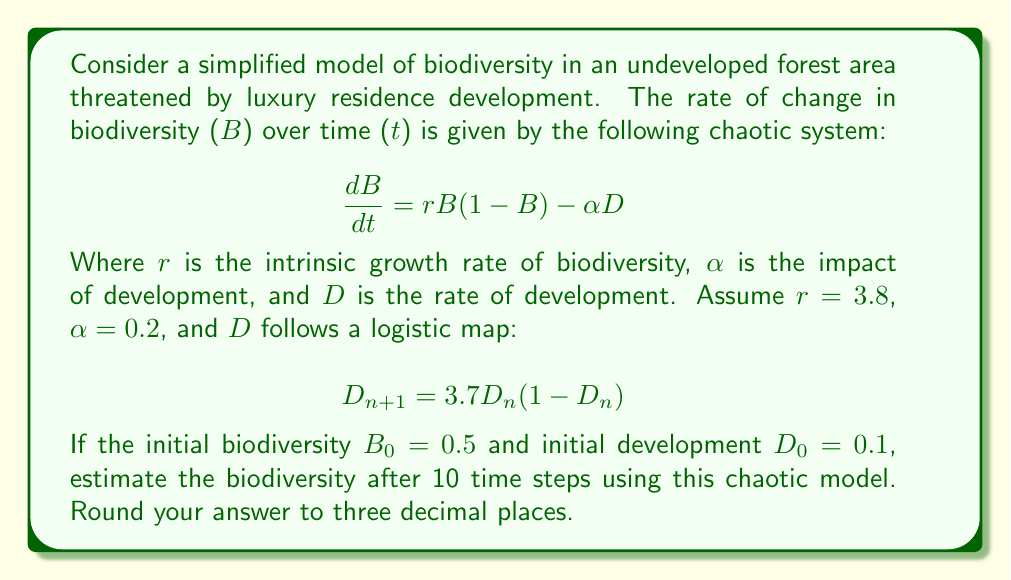Show me your answer to this math problem. To solve this problem, we need to use numerical methods to iterate the system over 10 time steps. We'll use the Euler method for the biodiversity equation and the given logistic map for the development rate.

Step 1: Set up initial conditions
B₀ = 0.5
D₀ = 0.1
r = 3.8
α = 0.2
Δt = 0.1 (assuming a small time step)

Step 2: Iterate the system for 10 time steps (n = 0 to 9)

For each step n:
1. Calculate D_{n+1} using the logistic map:
   $$D_{n+1} = 3.7D_n(1-D_n)$$

2. Calculate ΔB using the biodiversity equation:
   $$\Delta B = [rB_n(1-B_n) - \alpha D_n] \Delta t$$

3. Update B_{n+1}:
   $$B_{n+1} = B_n + \Delta B$$

Let's perform the first few iterations:

n = 0:
D₁ = 3.7 * 0.1 * (1 - 0.1) = 0.333
ΔB = [3.8 * 0.5 * (1 - 0.5) - 0.2 * 0.1] * 0.1 = 0.0455
B₁ = 0.5 + 0.0455 = 0.5455

n = 1:
D₂ = 3.7 * 0.333 * (1 - 0.333) = 0.822
ΔB = [3.8 * 0.5455 * (1 - 0.5455) - 0.2 * 0.333] * 0.1 = 0.0399
B₂ = 0.5455 + 0.0399 = 0.5854

Continuing this process for the remaining steps...

n = 9:
D₁₀ ≈ 0.370
B₁₀ ≈ 0.891

The final biodiversity value after 10 time steps is approximately 0.891.
Answer: 0.891 